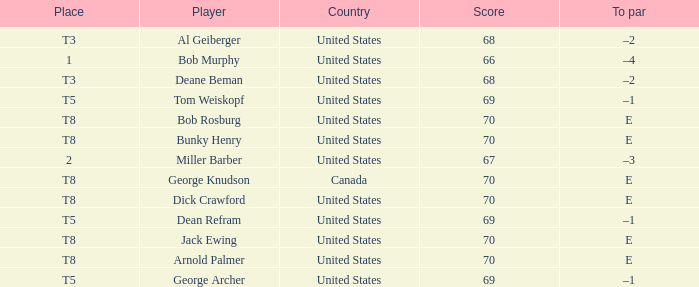Which country is George Archer from? United States. 